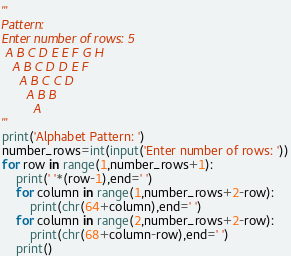<code> <loc_0><loc_0><loc_500><loc_500><_Python_>'''
Pattern:
Enter number of rows: 5
 A B C D E E F G H
   A B C D D E F
     A B C C D
       A B B
         A
'''
print('Alphabet Pattern: ')
number_rows=int(input('Enter number of rows: '))
for row in range(1,number_rows+1):
	print(' '*(row-1),end=' ')
	for column in range(1,number_rows+2-row):
		print(chr(64+column),end=' ')
	for column in range(2,number_rows+2-row):
		print(chr(68+column-row),end=' ')
	print()</code> 